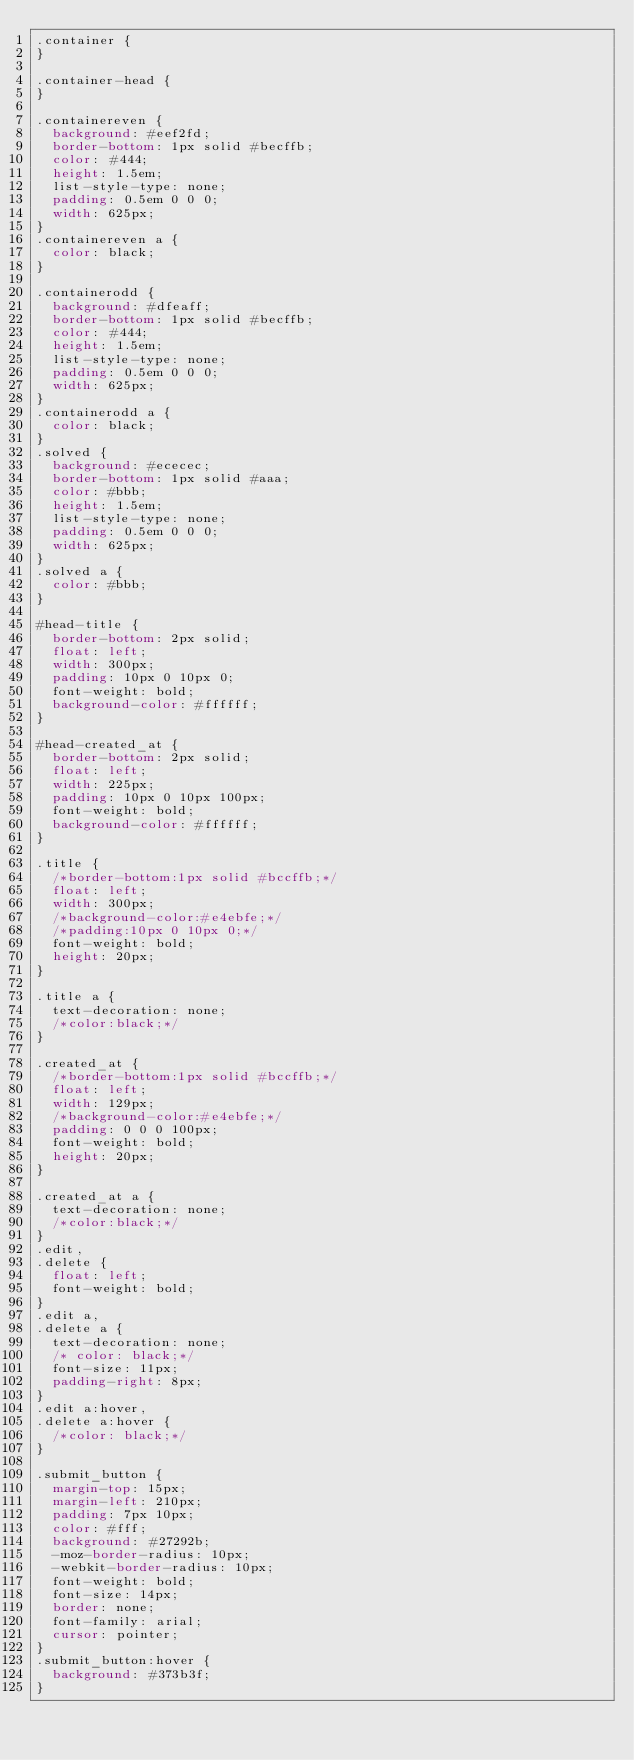Convert code to text. <code><loc_0><loc_0><loc_500><loc_500><_CSS_>.container {
}

.container-head {
}

.containereven {
  background: #eef2fd;
  border-bottom: 1px solid #becffb;
  color: #444;
  height: 1.5em;
  list-style-type: none;
  padding: 0.5em 0 0 0;
  width: 625px;
}
.containereven a {
  color: black;
}

.containerodd {
  background: #dfeaff;
  border-bottom: 1px solid #becffb;
  color: #444;
  height: 1.5em;
  list-style-type: none;
  padding: 0.5em 0 0 0;
  width: 625px;
}
.containerodd a {
  color: black;
}
.solved {
  background: #ececec;
  border-bottom: 1px solid #aaa;
  color: #bbb;
  height: 1.5em;
  list-style-type: none;
  padding: 0.5em 0 0 0;
  width: 625px;
}
.solved a {
  color: #bbb;
}

#head-title {
  border-bottom: 2px solid;
  float: left;
  width: 300px;
  padding: 10px 0 10px 0;
  font-weight: bold;
  background-color: #ffffff;
}

#head-created_at {
  border-bottom: 2px solid;
  float: left;
  width: 225px;
  padding: 10px 0 10px 100px;
  font-weight: bold;
  background-color: #ffffff;
}

.title {
  /*border-bottom:1px solid #bccffb;*/
  float: left;
  width: 300px;
  /*background-color:#e4ebfe;*/
  /*padding:10px 0 10px 0;*/
  font-weight: bold;
  height: 20px;
}

.title a {
  text-decoration: none;
  /*color:black;*/
}

.created_at {
  /*border-bottom:1px solid #bccffb;*/
  float: left;
  width: 129px;
  /*background-color:#e4ebfe;*/
  padding: 0 0 0 100px;
  font-weight: bold;
  height: 20px;
}

.created_at a {
  text-decoration: none;
  /*color:black;*/
}
.edit,
.delete {
  float: left;
  font-weight: bold;
}
.edit a,
.delete a {
  text-decoration: none;
  /* color: black;*/
  font-size: 11px;
  padding-right: 8px;
}
.edit a:hover,
.delete a:hover {
  /*color: black;*/
}

.submit_button {
  margin-top: 15px;
  margin-left: 210px;
  padding: 7px 10px;
  color: #fff;
  background: #27292b;
  -moz-border-radius: 10px;
  -webkit-border-radius: 10px;
  font-weight: bold;
  font-size: 14px;
  border: none;
  font-family: arial;
  cursor: pointer;
}
.submit_button:hover {
  background: #373b3f;
}
</code> 